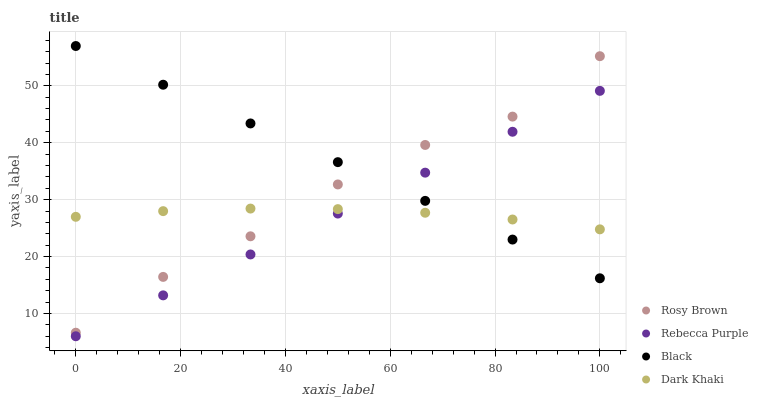Does Dark Khaki have the minimum area under the curve?
Answer yes or no. Yes. Does Black have the maximum area under the curve?
Answer yes or no. Yes. Does Rosy Brown have the minimum area under the curve?
Answer yes or no. No. Does Rosy Brown have the maximum area under the curve?
Answer yes or no. No. Is Black the smoothest?
Answer yes or no. Yes. Is Rosy Brown the roughest?
Answer yes or no. Yes. Is Rosy Brown the smoothest?
Answer yes or no. No. Is Black the roughest?
Answer yes or no. No. Does Rebecca Purple have the lowest value?
Answer yes or no. Yes. Does Rosy Brown have the lowest value?
Answer yes or no. No. Does Black have the highest value?
Answer yes or no. Yes. Does Rosy Brown have the highest value?
Answer yes or no. No. Is Rebecca Purple less than Rosy Brown?
Answer yes or no. Yes. Is Rosy Brown greater than Rebecca Purple?
Answer yes or no. Yes. Does Dark Khaki intersect Rebecca Purple?
Answer yes or no. Yes. Is Dark Khaki less than Rebecca Purple?
Answer yes or no. No. Is Dark Khaki greater than Rebecca Purple?
Answer yes or no. No. Does Rebecca Purple intersect Rosy Brown?
Answer yes or no. No. 